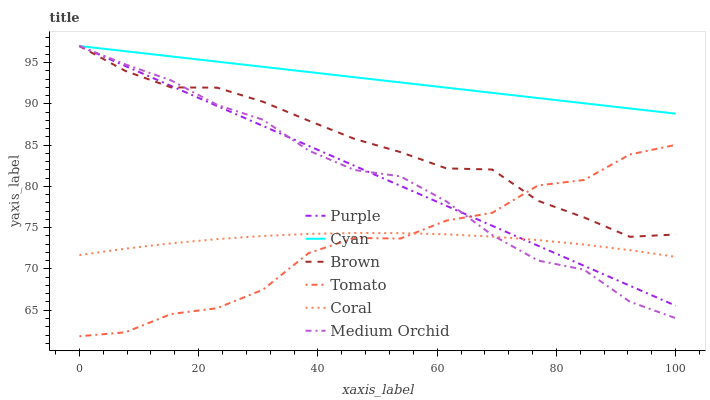Does Tomato have the minimum area under the curve?
Answer yes or no. Yes. Does Cyan have the maximum area under the curve?
Answer yes or no. Yes. Does Brown have the minimum area under the curve?
Answer yes or no. No. Does Brown have the maximum area under the curve?
Answer yes or no. No. Is Cyan the smoothest?
Answer yes or no. Yes. Is Tomato the roughest?
Answer yes or no. Yes. Is Brown the smoothest?
Answer yes or no. No. Is Brown the roughest?
Answer yes or no. No. Does Tomato have the lowest value?
Answer yes or no. Yes. Does Brown have the lowest value?
Answer yes or no. No. Does Cyan have the highest value?
Answer yes or no. Yes. Does Coral have the highest value?
Answer yes or no. No. Is Tomato less than Cyan?
Answer yes or no. Yes. Is Cyan greater than Coral?
Answer yes or no. Yes. Does Brown intersect Cyan?
Answer yes or no. Yes. Is Brown less than Cyan?
Answer yes or no. No. Is Brown greater than Cyan?
Answer yes or no. No. Does Tomato intersect Cyan?
Answer yes or no. No. 